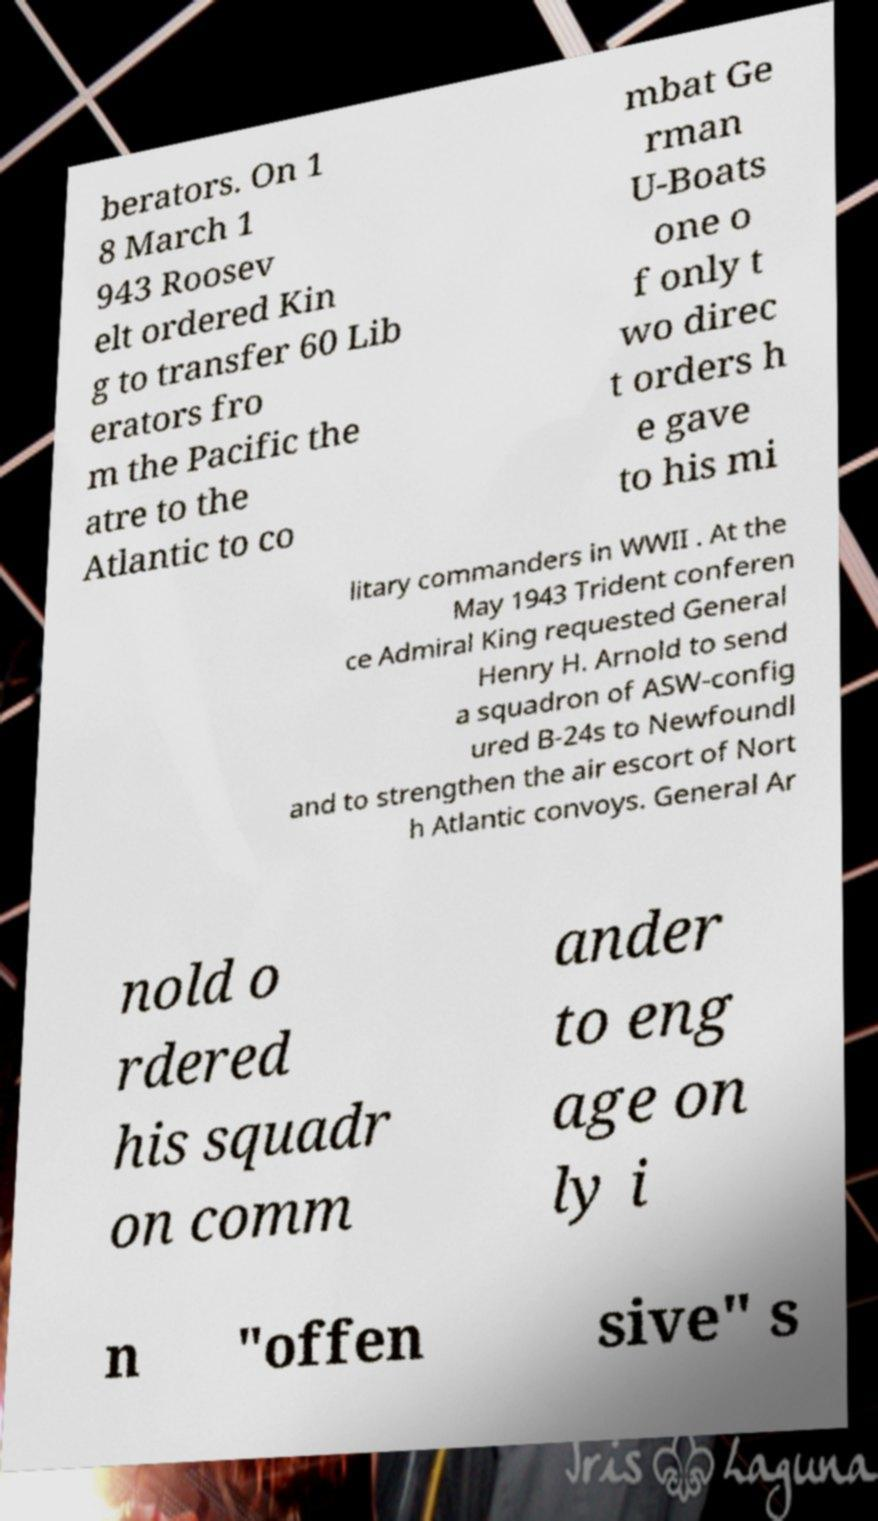There's text embedded in this image that I need extracted. Can you transcribe it verbatim? berators. On 1 8 March 1 943 Roosev elt ordered Kin g to transfer 60 Lib erators fro m the Pacific the atre to the Atlantic to co mbat Ge rman U-Boats one o f only t wo direc t orders h e gave to his mi litary commanders in WWII . At the May 1943 Trident conferen ce Admiral King requested General Henry H. Arnold to send a squadron of ASW-config ured B-24s to Newfoundl and to strengthen the air escort of Nort h Atlantic convoys. General Ar nold o rdered his squadr on comm ander to eng age on ly i n "offen sive" s 